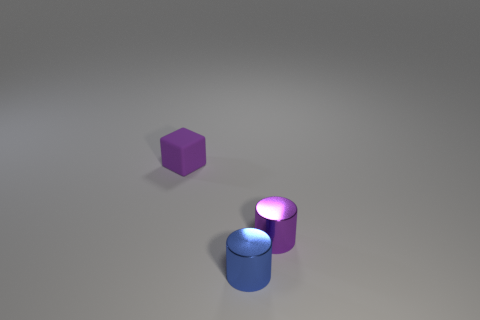Do the purple shiny object and the cylinder that is left of the small purple cylinder have the same size?
Offer a terse response. Yes. What is the shape of the purple object that is to the left of the tiny metallic cylinder that is behind the blue cylinder?
Offer a very short reply. Cube. Are there fewer blue metal things to the left of the purple metal thing than purple blocks?
Offer a terse response. No. What shape is the small object that is the same color as the rubber block?
Your answer should be very brief. Cylinder. What number of other objects have the same size as the purple metal thing?
Make the answer very short. 2. What shape is the tiny purple thing left of the tiny blue shiny object?
Your answer should be compact. Cube. Are there fewer big gray metallic cubes than purple matte blocks?
Keep it short and to the point. Yes. Is there any other thing that is the same color as the cube?
Your answer should be very brief. Yes. What is the size of the purple object that is right of the tiny purple block?
Ensure brevity in your answer.  Small. Is the number of big purple rubber cylinders greater than the number of tiny cubes?
Your answer should be very brief. No. 